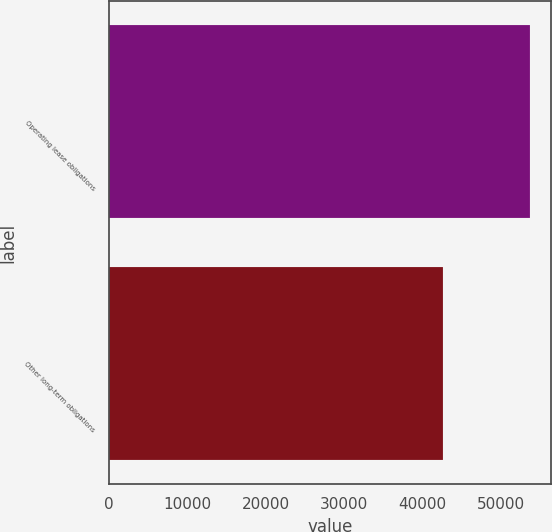Convert chart to OTSL. <chart><loc_0><loc_0><loc_500><loc_500><bar_chart><fcel>Operating lease obligations<fcel>Other long-term obligations<nl><fcel>53712<fcel>42689<nl></chart> 